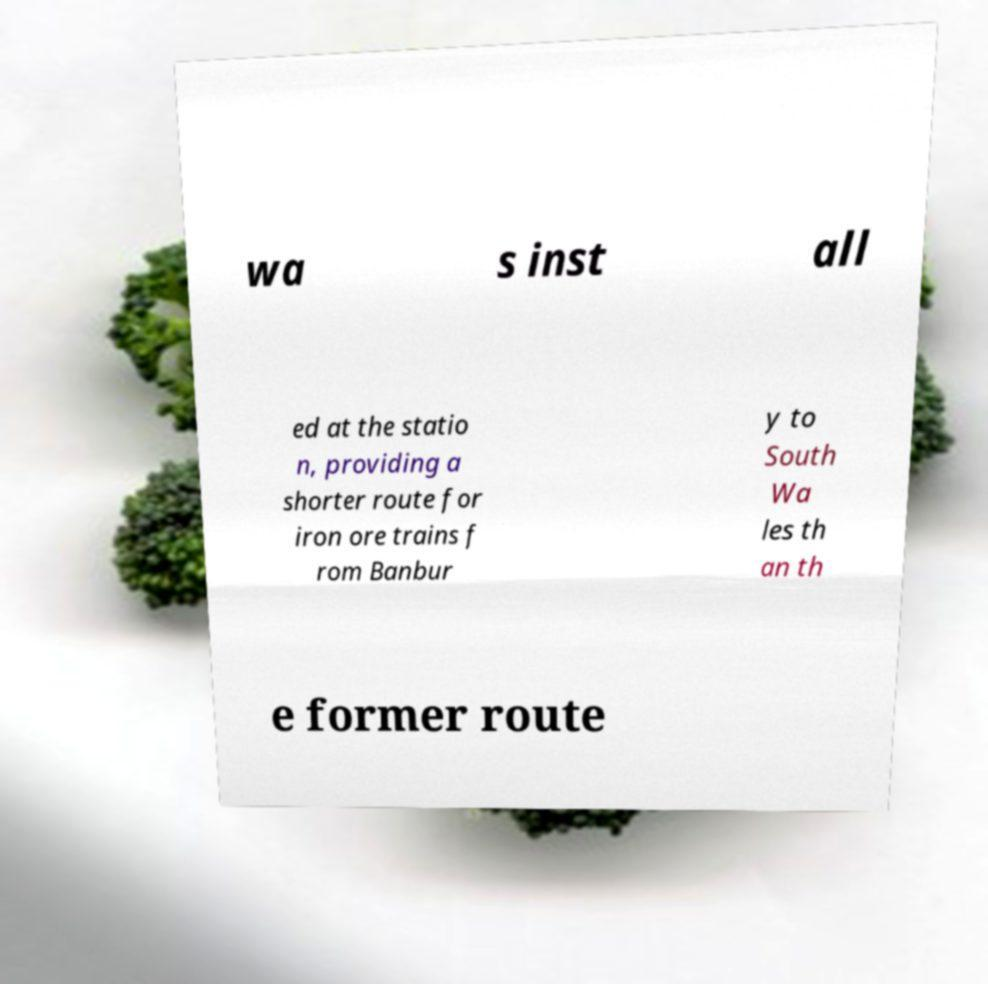Can you accurately transcribe the text from the provided image for me? wa s inst all ed at the statio n, providing a shorter route for iron ore trains f rom Banbur y to South Wa les th an th e former route 